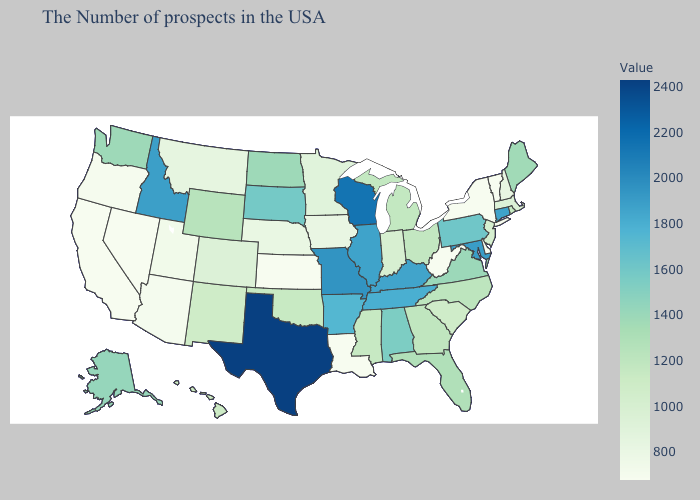Does Maine have the lowest value in the Northeast?
Answer briefly. No. Among the states that border Washington , does Oregon have the highest value?
Concise answer only. No. Which states have the highest value in the USA?
Short answer required. Texas. Which states hav the highest value in the Northeast?
Concise answer only. Connecticut. Does North Dakota have a higher value than West Virginia?
Quick response, please. Yes. Which states have the lowest value in the USA?
Write a very short answer. Vermont, New York, Delaware, West Virginia, Louisiana, Kansas, Nevada, California. 